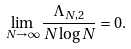Convert formula to latex. <formula><loc_0><loc_0><loc_500><loc_500>\lim _ { N \rightarrow \infty } \frac { \Lambda _ { N , 2 } } { N \log N } = 0 .</formula> 